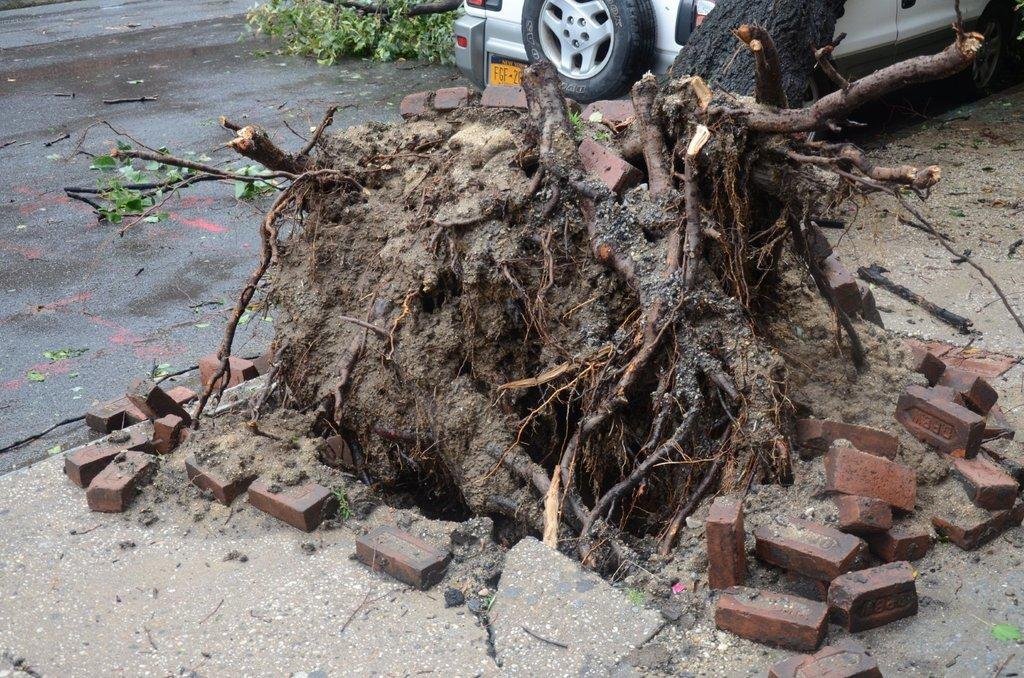What type of damage can be seen on the footpath in the image? There are cracks on the footpath in the image. What natural element is depicted as having fallen in the image? There is a fallen tree with roots in the image. What mode of transportation can be seen on the road in the image? A vehicle is visible on the road in the image. What part of a tree is present in the image? Branches of a tree are present in the image. How many dimes are scattered around the fallen tree in the image? There are no dimes present in the image; it features a fallen tree with roots and other elements mentioned in the facts. What type of footwear is shown on the branches of the tree in the image? There is no footwear, such as a boot, present on the branches of the tree in the image. 